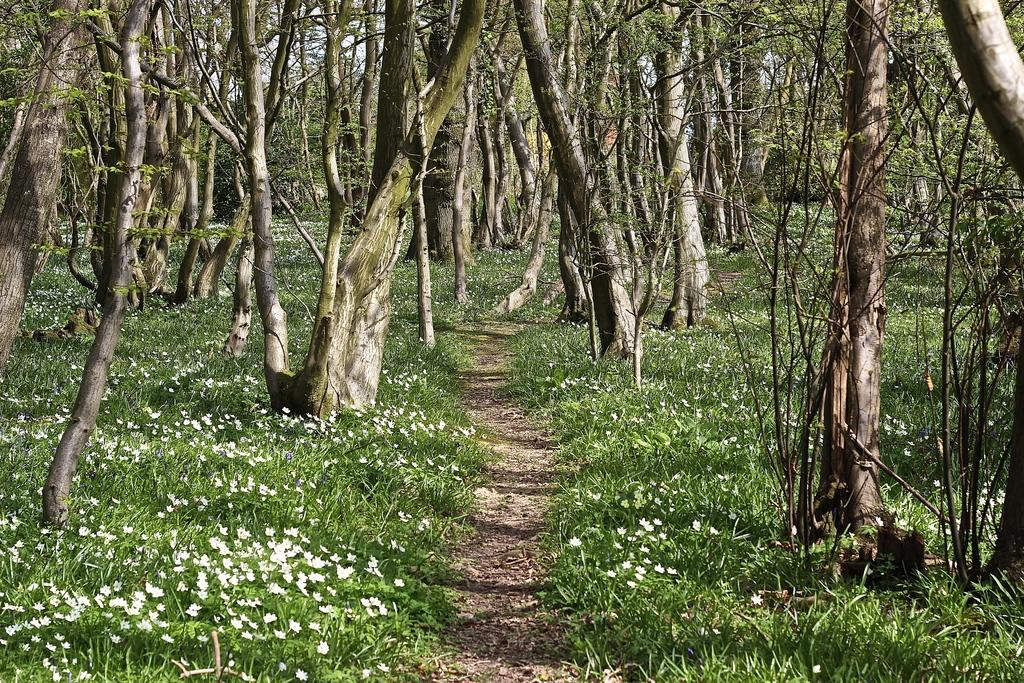What type of vegetation is predominant in the image? There are many trees in the image. Can you describe the ground between the trees? There is grass with some flowers in between the trees. What type of metal can be seen in the image? There is no metal visible in the image; it primarily features trees and grass with flowers. 